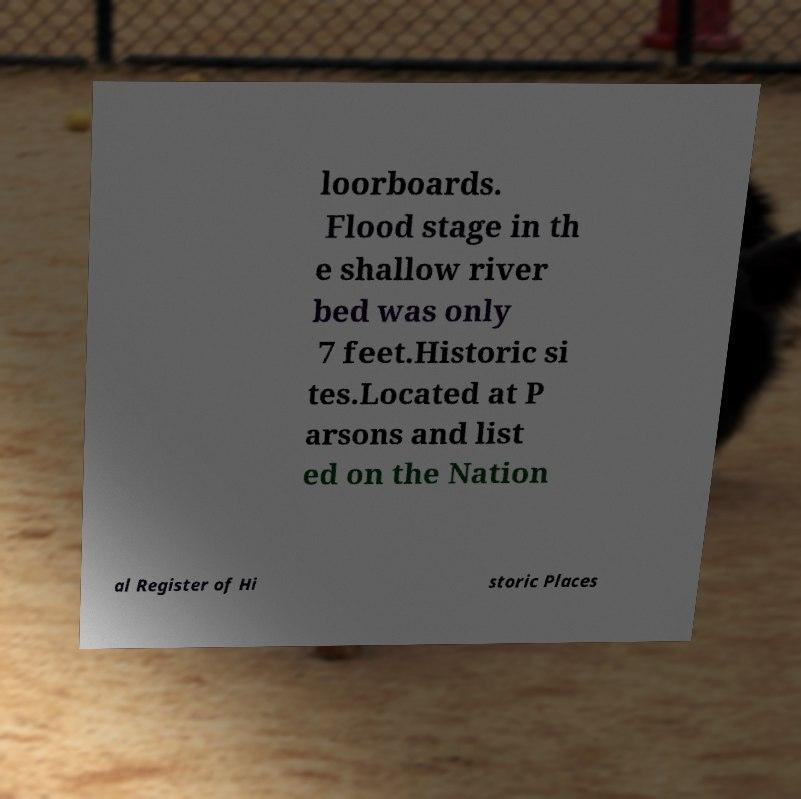There's text embedded in this image that I need extracted. Can you transcribe it verbatim? loorboards. Flood stage in th e shallow river bed was only 7 feet.Historic si tes.Located at P arsons and list ed on the Nation al Register of Hi storic Places 